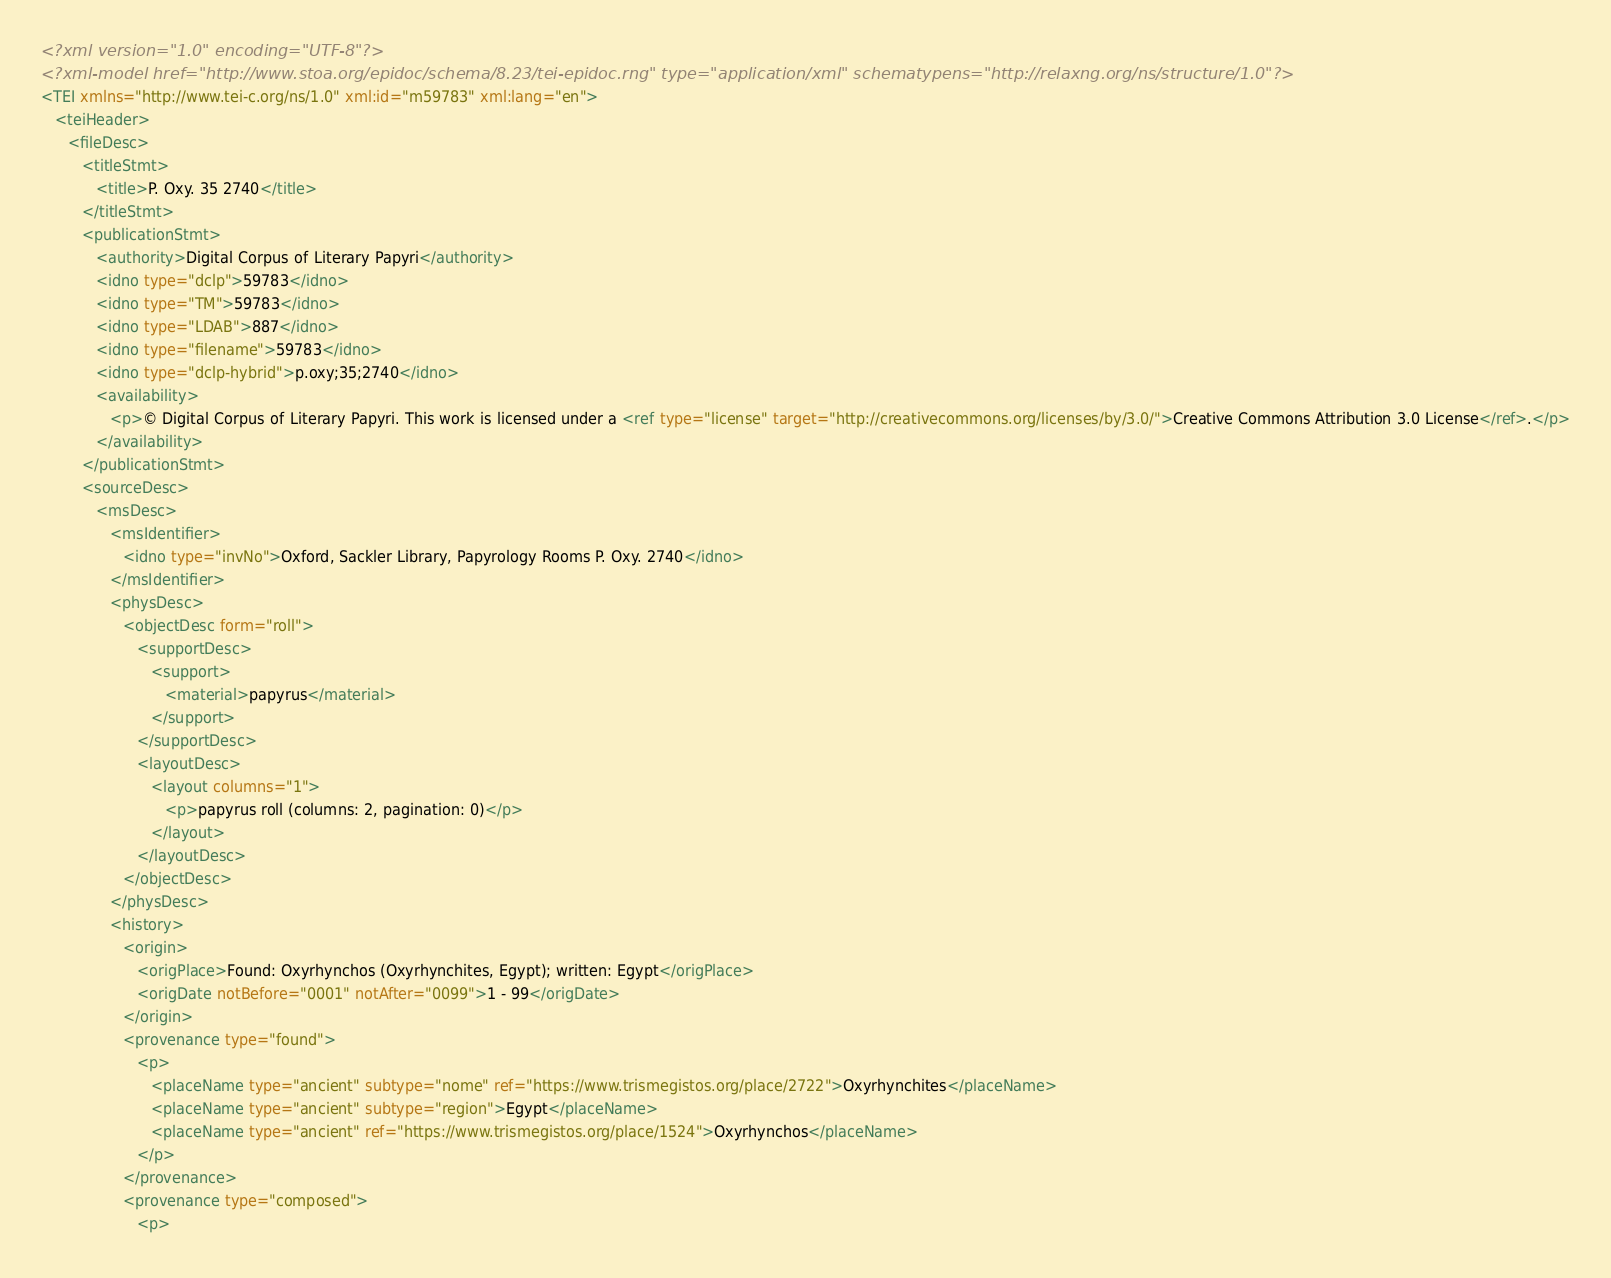<code> <loc_0><loc_0><loc_500><loc_500><_XML_><?xml version="1.0" encoding="UTF-8"?>
<?xml-model href="http://www.stoa.org/epidoc/schema/8.23/tei-epidoc.rng" type="application/xml" schematypens="http://relaxng.org/ns/structure/1.0"?>
<TEI xmlns="http://www.tei-c.org/ns/1.0" xml:id="m59783" xml:lang="en">
   <teiHeader>
      <fileDesc>
         <titleStmt>
            <title>P. Oxy. 35 2740</title>
         </titleStmt>
         <publicationStmt>
            <authority>Digital Corpus of Literary Papyri</authority>
            <idno type="dclp">59783</idno>
            <idno type="TM">59783</idno>
            <idno type="LDAB">887</idno>
            <idno type="filename">59783</idno>
            <idno type="dclp-hybrid">p.oxy;35;2740</idno>
            <availability>
               <p>© Digital Corpus of Literary Papyri. This work is licensed under a <ref type="license" target="http://creativecommons.org/licenses/by/3.0/">Creative Commons Attribution 3.0 License</ref>.</p>
            </availability>
         </publicationStmt>
         <sourceDesc>
            <msDesc>
               <msIdentifier>
                  <idno type="invNo">Oxford, Sackler Library, Papyrology Rooms P. Oxy. 2740</idno>
               </msIdentifier>
               <physDesc>
                  <objectDesc form="roll">
                     <supportDesc>
                        <support>
                           <material>papyrus</material>
                        </support>
                     </supportDesc>
                     <layoutDesc>
                        <layout columns="1">
                           <p>papyrus roll (columns: 2, pagination: 0)</p>
                        </layout>
                     </layoutDesc>
                  </objectDesc>
               </physDesc>
               <history>
                  <origin>
                     <origPlace>Found: Oxyrhynchos (Oxyrhynchites, Egypt); written: Egypt</origPlace>
                     <origDate notBefore="0001" notAfter="0099">1 - 99</origDate>
                  </origin>
                  <provenance type="found">
                     <p>
                        <placeName type="ancient" subtype="nome" ref="https://www.trismegistos.org/place/2722">Oxyrhynchites</placeName>
                        <placeName type="ancient" subtype="region">Egypt</placeName>
                        <placeName type="ancient" ref="https://www.trismegistos.org/place/1524">Oxyrhynchos</placeName>
                     </p>
                  </provenance>
                  <provenance type="composed">
                     <p></code> 